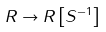Convert formula to latex. <formula><loc_0><loc_0><loc_500><loc_500>R \to R \left [ S ^ { - 1 } \right ]</formula> 